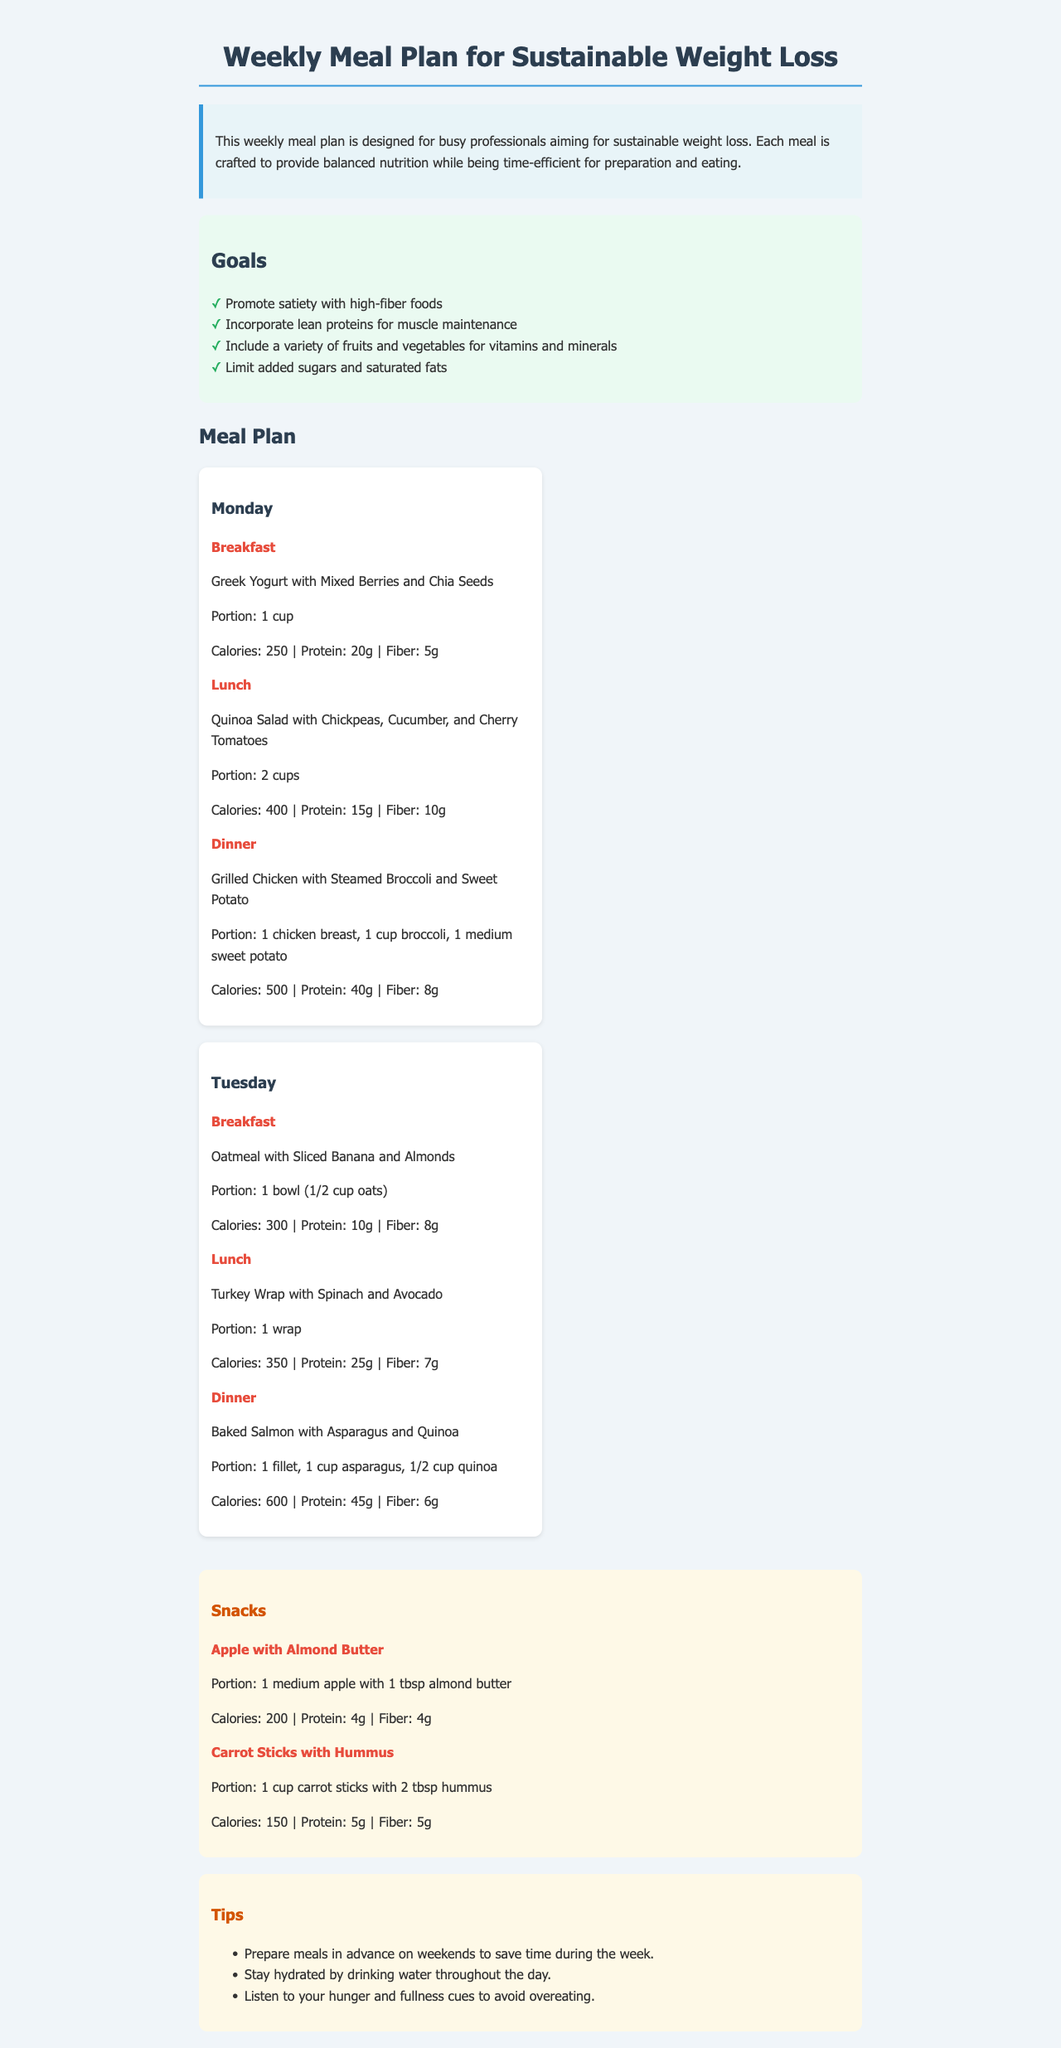What is the portion size for breakfast on Monday? The portion size for breakfast on Monday is provided in the meal description.
Answer: 1 cup How many grams of protein are in Tuesday's lunch? The protein content for Tuesday's lunch is listed in the meal details.
Answer: 25g What is the total calorie count for Monday's dinner? The total calorie count for Monday's dinner is found in the meal details section.
Answer: 500 How many goals are outlined in the meal plan? The number of goals can be determined by counting the items listed under the goals section.
Answer: 4 What snack includes almond butter? The snack that includes almond butter is mentioned in the snacks section of the document.
Answer: Apple with Almond Butter What food group is emphasized for muscle maintenance? The document specifies an emphasis on a certain food group in the goals section.
Answer: Lean proteins How many cups of carrot sticks are included in the hummus snack? The amount related to the carrot sticks snack is explicitly mentioned in the meal description.
Answer: 1 cup What meal is suggested for Tuesday’s dinner? The dinner option for Tuesday is stated directly in the meal plan.
Answer: Baked Salmon with Asparagus and Quinoa What is the calorie count for oatmeal on Tuesday for breakfast? The calorie count for Tuesday’s breakfast is provided under the meal details for that day.
Answer: 300 